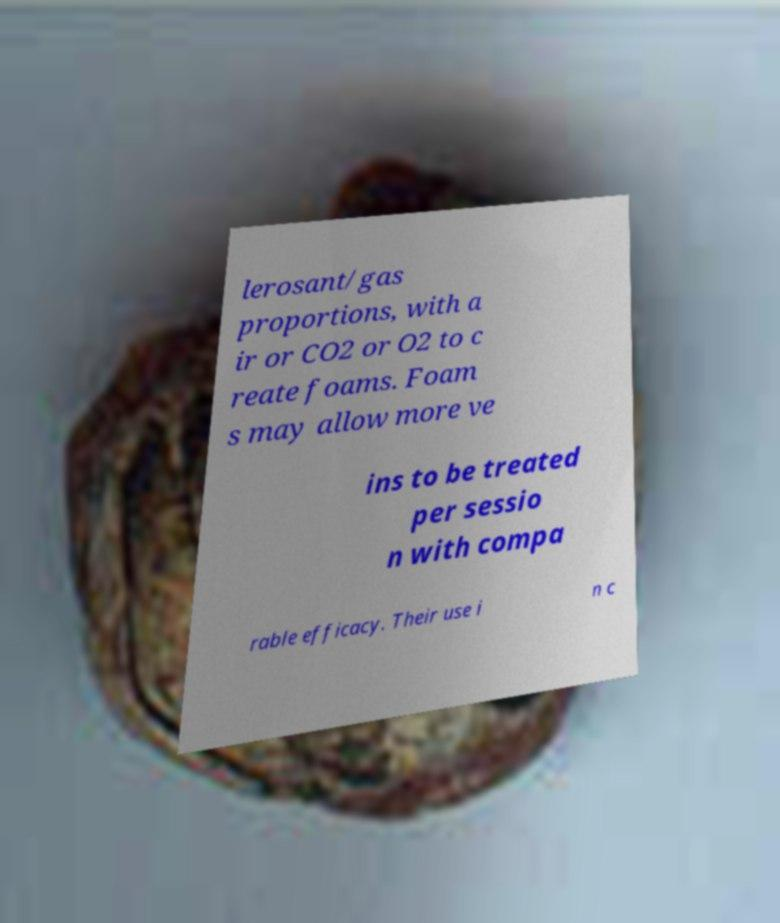Can you accurately transcribe the text from the provided image for me? lerosant/gas proportions, with a ir or CO2 or O2 to c reate foams. Foam s may allow more ve ins to be treated per sessio n with compa rable efficacy. Their use i n c 